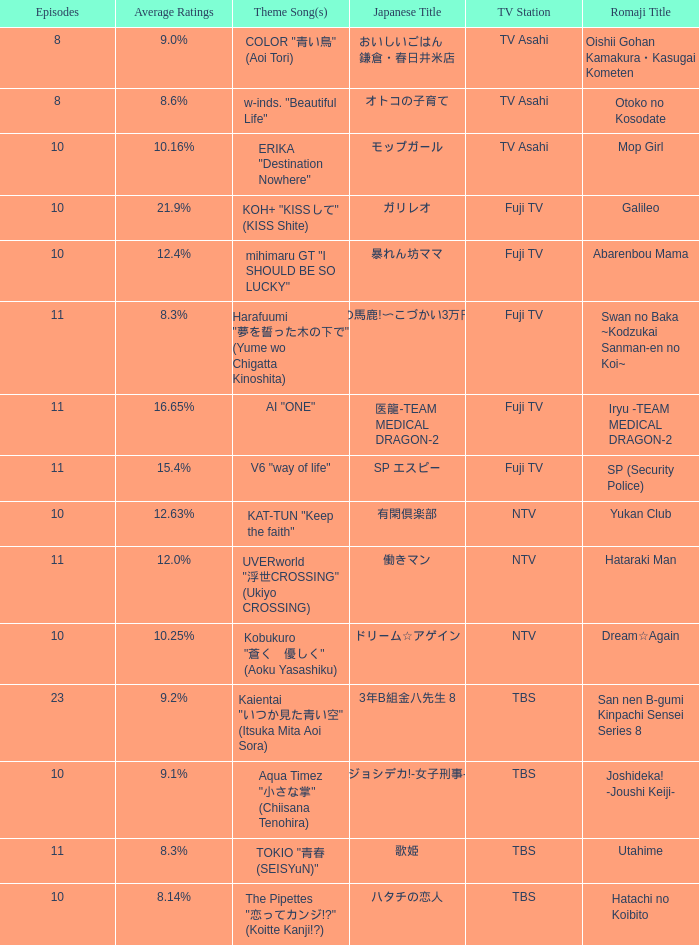What is the main tune of 働きマン? UVERworld "浮世CROSSING" (Ukiyo CROSSING). 